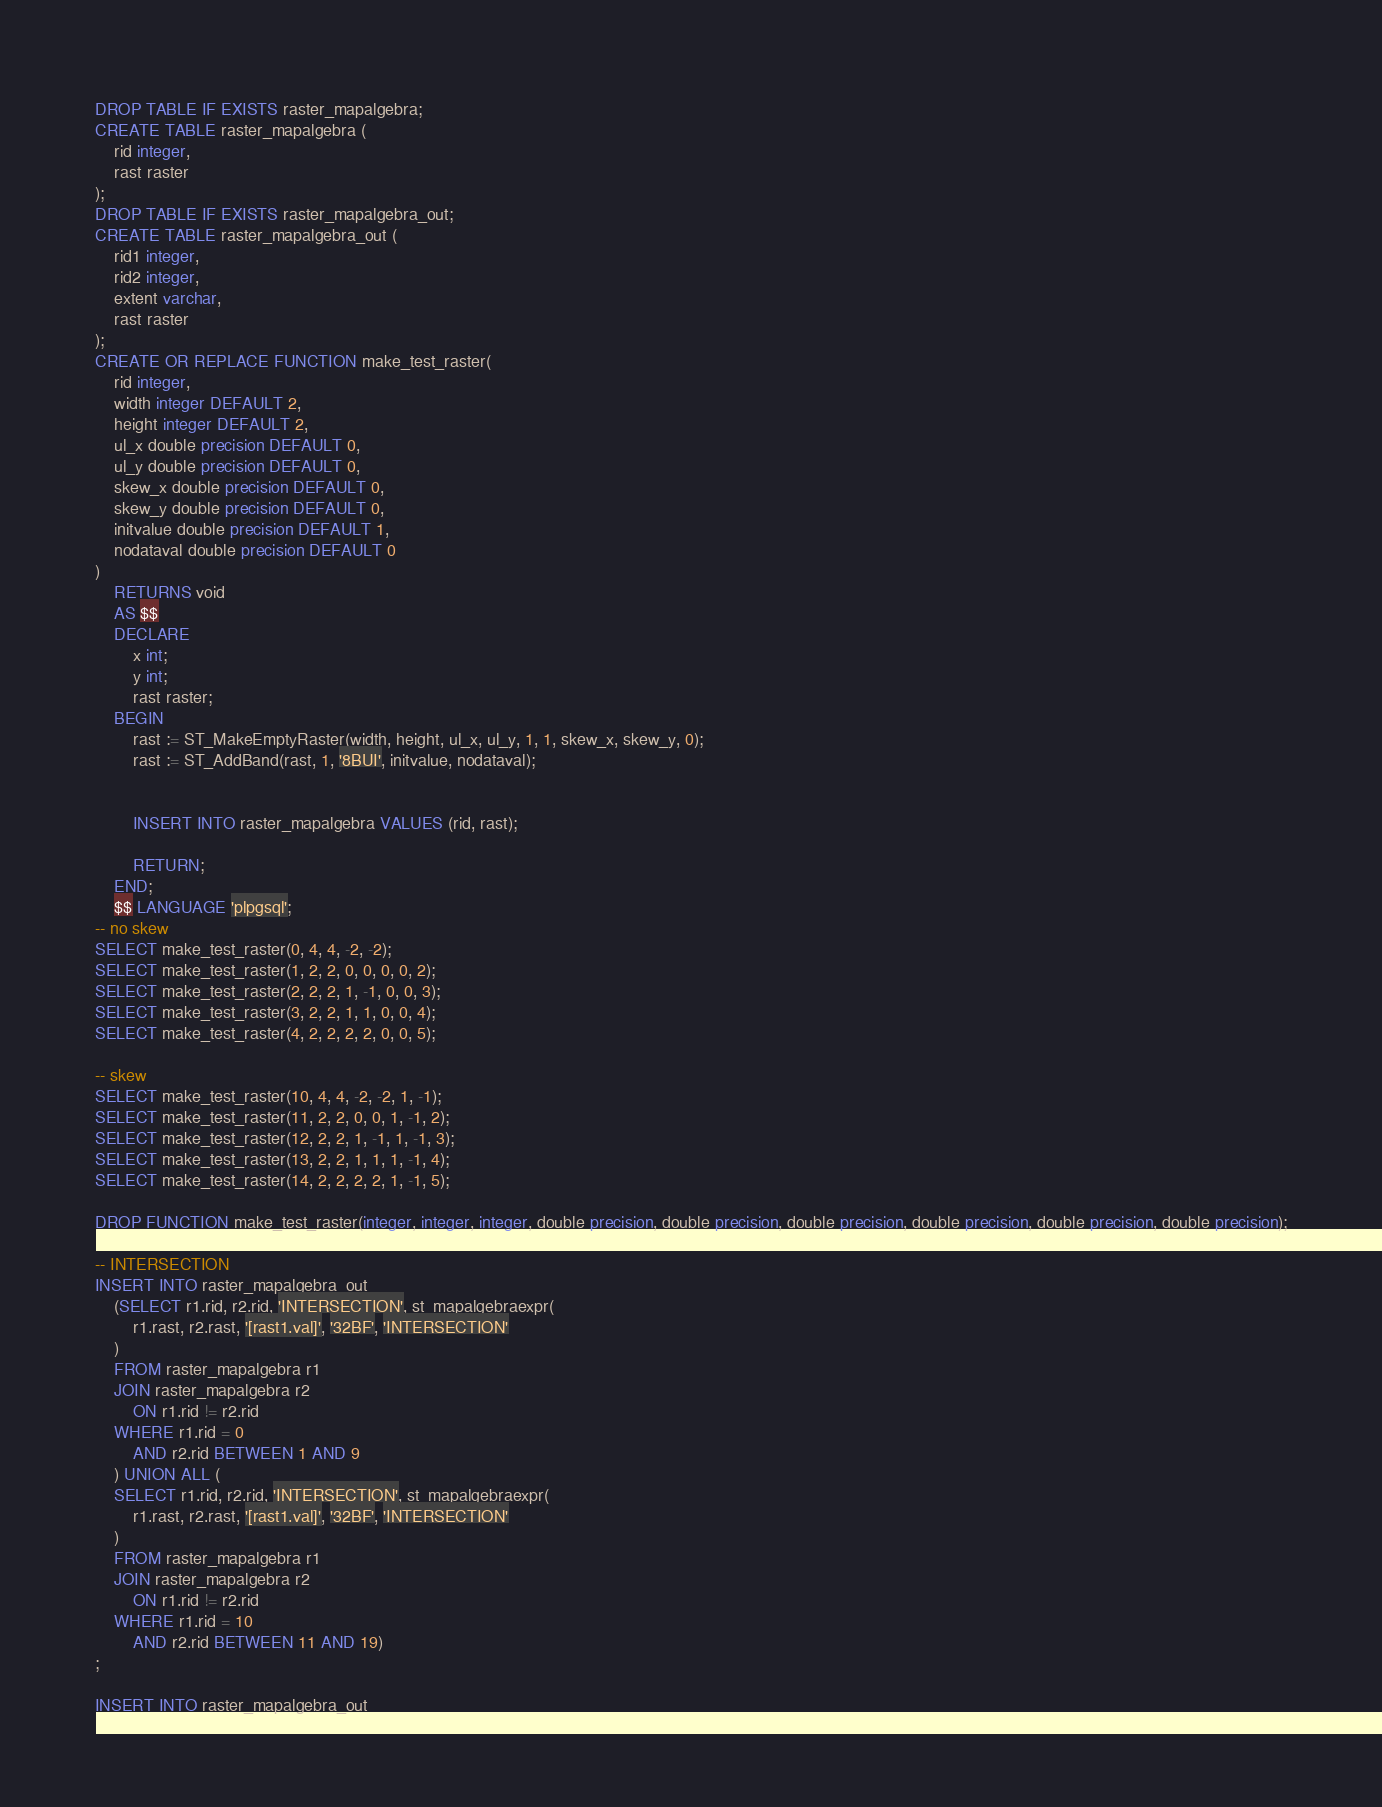<code> <loc_0><loc_0><loc_500><loc_500><_SQL_>DROP TABLE IF EXISTS raster_mapalgebra;
CREATE TABLE raster_mapalgebra (
	rid integer,
	rast raster
);
DROP TABLE IF EXISTS raster_mapalgebra_out;
CREATE TABLE raster_mapalgebra_out (
	rid1 integer,
	rid2 integer,
	extent varchar,
	rast raster
);
CREATE OR REPLACE FUNCTION make_test_raster(
	rid integer,
	width integer DEFAULT 2,
	height integer DEFAULT 2,
	ul_x double precision DEFAULT 0,
	ul_y double precision DEFAULT 0,
	skew_x double precision DEFAULT 0,
	skew_y double precision DEFAULT 0,
	initvalue double precision DEFAULT 1,
	nodataval double precision DEFAULT 0
)
	RETURNS void
	AS $$
	DECLARE
		x int;
		y int;
		rast raster;
	BEGIN
		rast := ST_MakeEmptyRaster(width, height, ul_x, ul_y, 1, 1, skew_x, skew_y, 0);
		rast := ST_AddBand(rast, 1, '8BUI', initvalue, nodataval);


		INSERT INTO raster_mapalgebra VALUES (rid, rast);

		RETURN;
	END;
	$$ LANGUAGE 'plpgsql';
-- no skew
SELECT make_test_raster(0, 4, 4, -2, -2);
SELECT make_test_raster(1, 2, 2, 0, 0, 0, 0, 2);
SELECT make_test_raster(2, 2, 2, 1, -1, 0, 0, 3);
SELECT make_test_raster(3, 2, 2, 1, 1, 0, 0, 4);
SELECT make_test_raster(4, 2, 2, 2, 2, 0, 0, 5);

-- skew
SELECT make_test_raster(10, 4, 4, -2, -2, 1, -1);
SELECT make_test_raster(11, 2, 2, 0, 0, 1, -1, 2);
SELECT make_test_raster(12, 2, 2, 1, -1, 1, -1, 3);
SELECT make_test_raster(13, 2, 2, 1, 1, 1, -1, 4);
SELECT make_test_raster(14, 2, 2, 2, 2, 1, -1, 5);

DROP FUNCTION make_test_raster(integer, integer, integer, double precision, double precision, double precision, double precision, double precision, double precision);

-- INTERSECTION
INSERT INTO raster_mapalgebra_out
	(SELECT r1.rid, r2.rid, 'INTERSECTION', st_mapalgebraexpr(
		r1.rast, r2.rast, '[rast1.val]', '32BF', 'INTERSECTION'
	)
	FROM raster_mapalgebra r1
	JOIN raster_mapalgebra r2
		ON r1.rid != r2.rid
	WHERE r1.rid = 0
		AND r2.rid BETWEEN 1 AND 9
	) UNION ALL (
	SELECT r1.rid, r2.rid, 'INTERSECTION', st_mapalgebraexpr(
		r1.rast, r2.rast, '[rast1.val]', '32BF', 'INTERSECTION'
	)
	FROM raster_mapalgebra r1
	JOIN raster_mapalgebra r2
		ON r1.rid != r2.rid
	WHERE r1.rid = 10
		AND r2.rid BETWEEN 11 AND 19)
;

INSERT INTO raster_mapalgebra_out</code> 